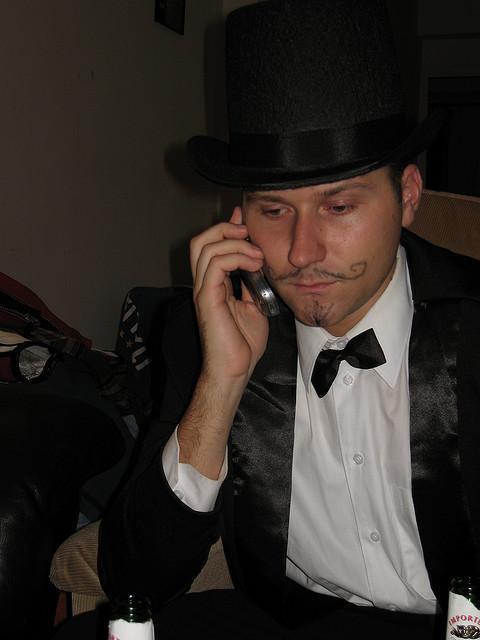What kind of phone is he using?
From the following set of four choices, select the accurate answer to respond to the question.
Options: Rotary, landline, cellular, pay. Cellular. 